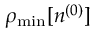Convert formula to latex. <formula><loc_0><loc_0><loc_500><loc_500>\rho _ { \min } [ n ^ { ( 0 ) } ]</formula> 